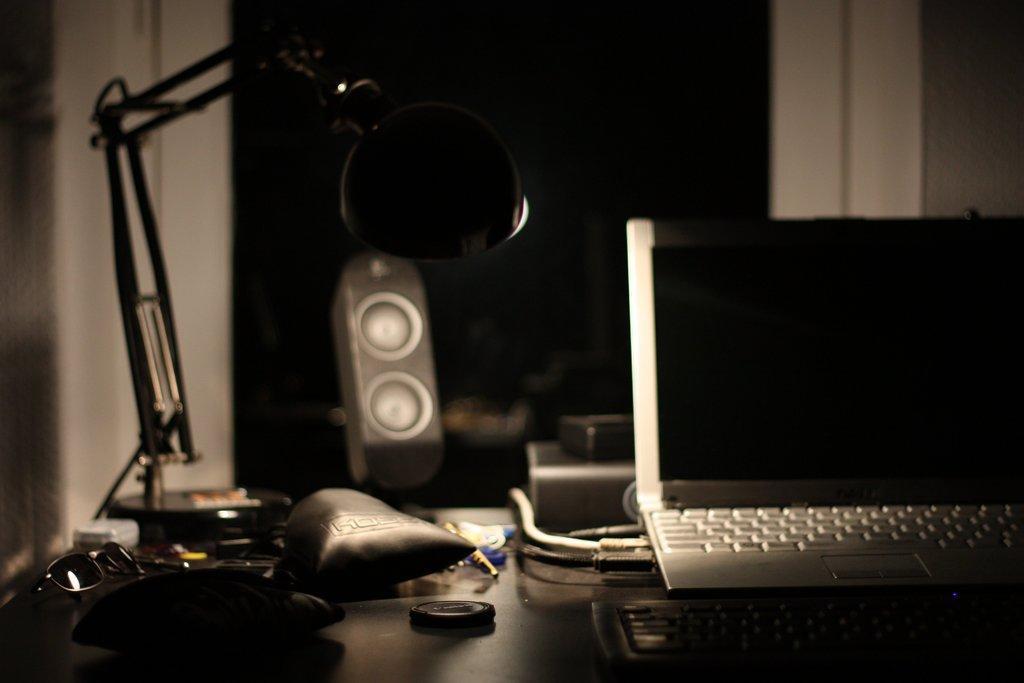Can you describe this image briefly? This is a picture clicked in the dark. Here I can see a table on which a laptop, lamp, goggles, wires, speaker, boxes and some more objects are placed. In the background, I can see a white color wall. 